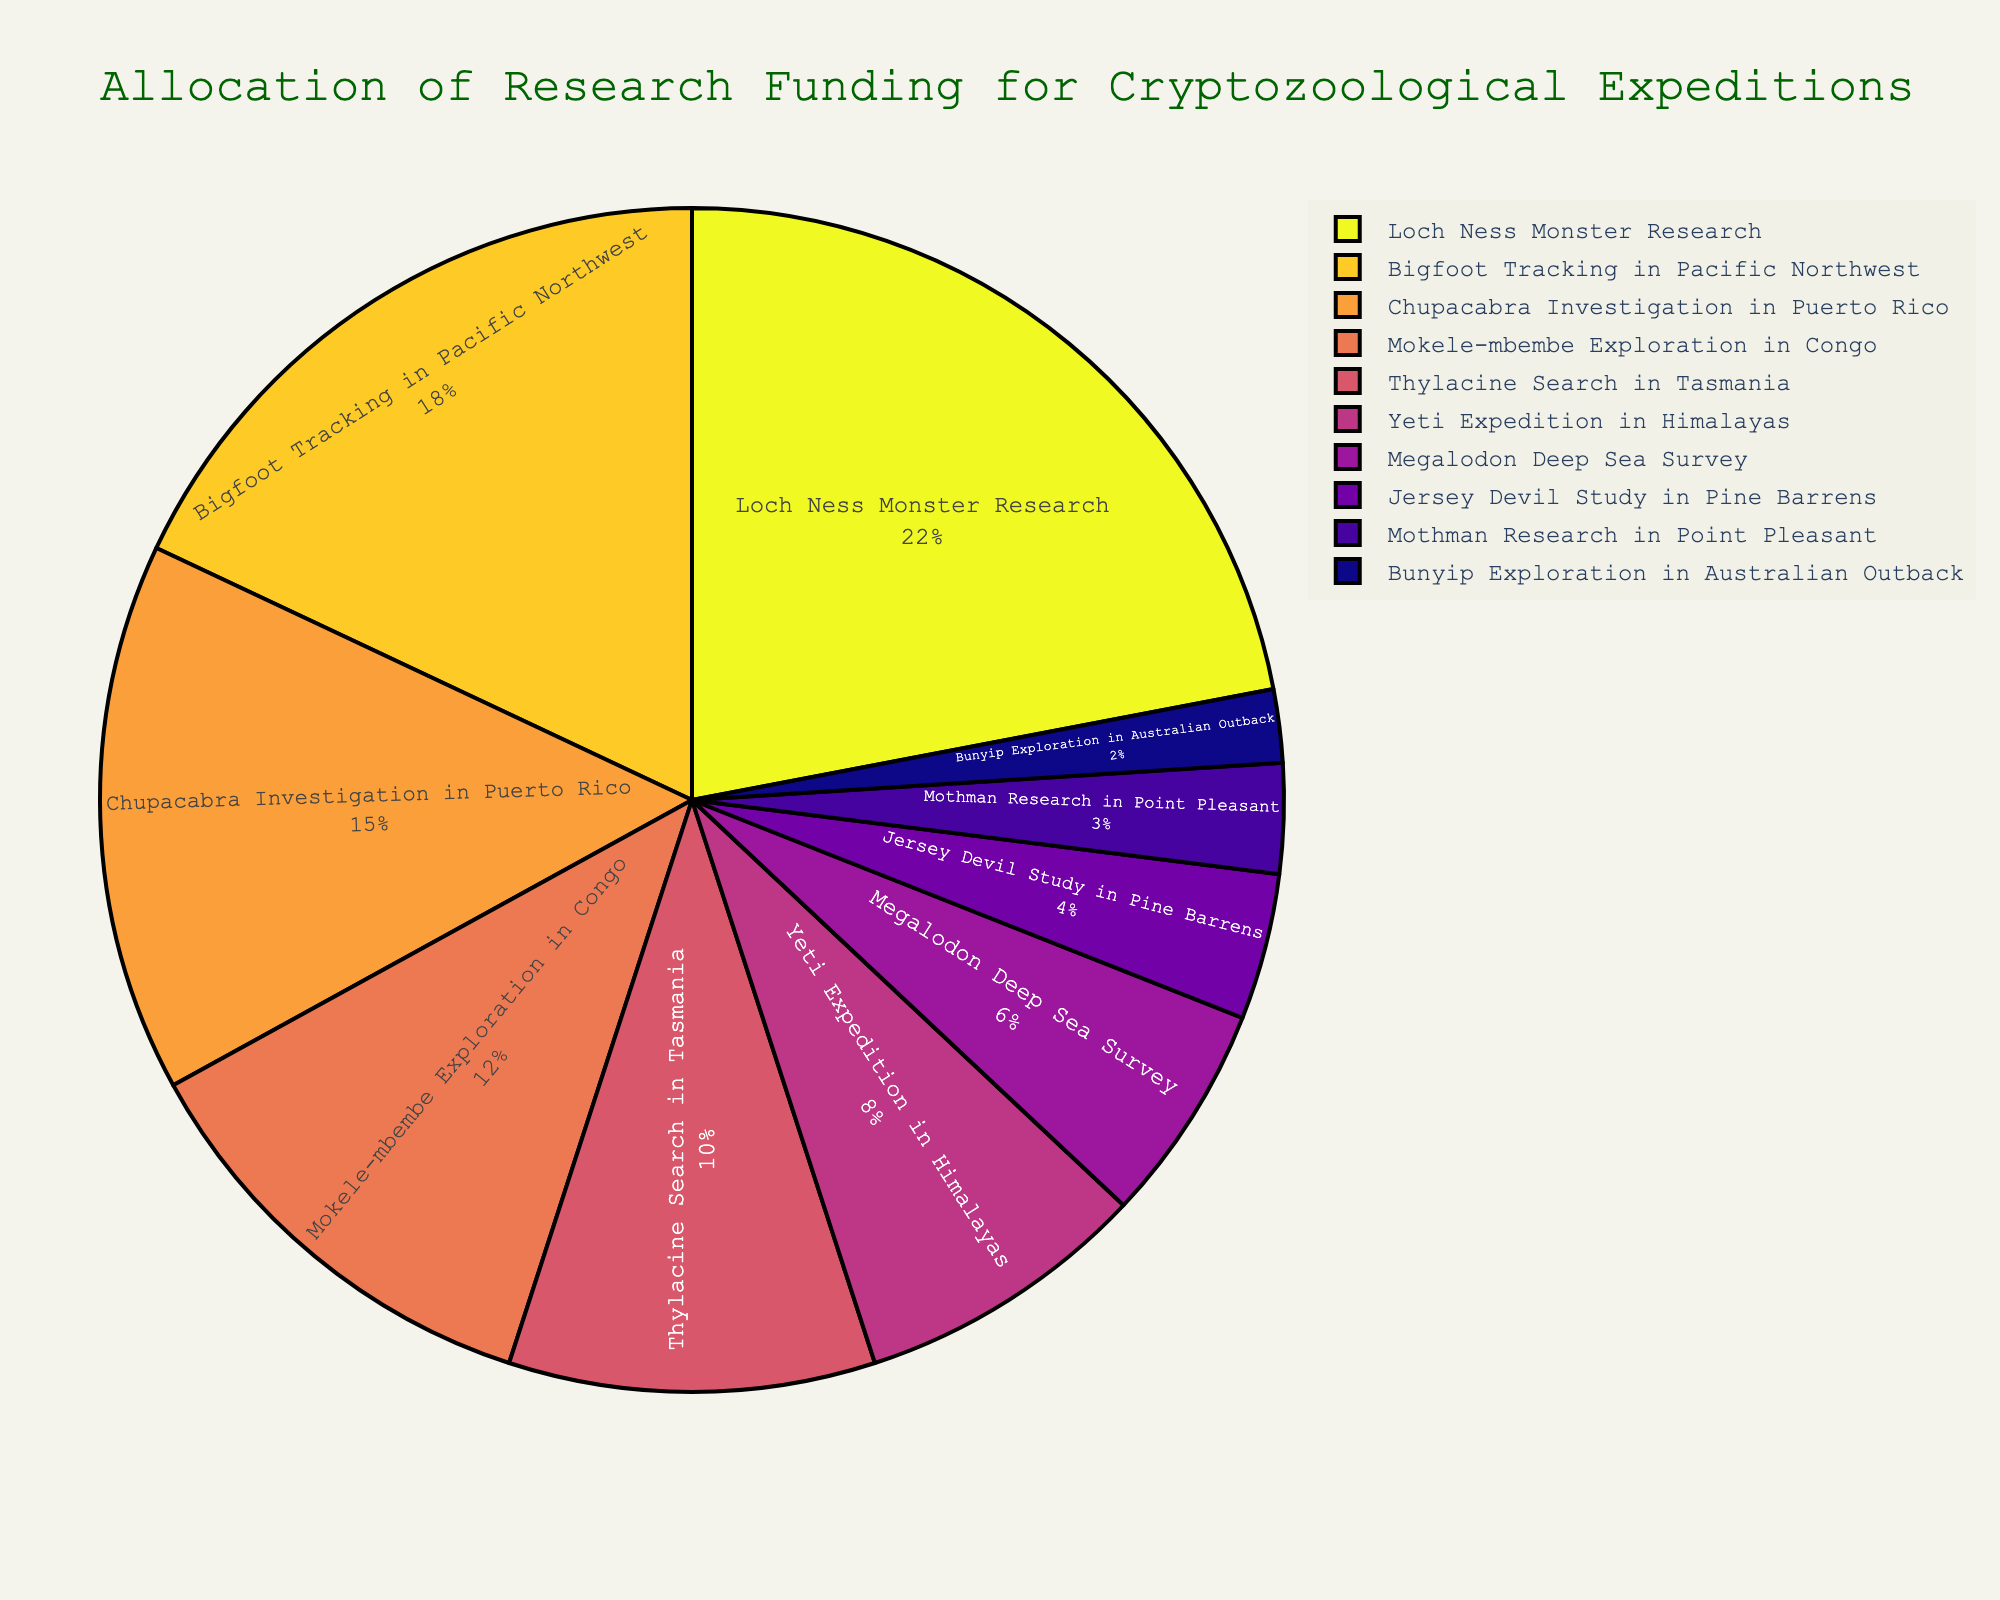Which expedition received the highest percentage of funding? The figure shows the allocation of research funding for various cryptozoological expeditions with percentages labeled. By finding the largest percentage in the pie chart, we identify 22% for Loch Ness Monster Research.
Answer: Loch Ness Monster Research What is the combined funding percentage for Bigfoot Tracking and Chupacabra Investigation? To find the combined funding, we sum the funding percentages for Bigfoot Tracking (18%) and Chupacabra Investigation (15%). Thus, 18 + 15 = 33.
Answer: 33% Which expedition received double the funding percentage of the Yeti Expedition? The funding percentage for the Yeti Expedition is 8%. Doubling this amount gives us 8 * 2 = 16%. The closest funding percentage in the pie chart to 16% is 15% for Chupacabra Investigation.
Answer: Chupacabra Investigation What is the difference in funding percentage between the highest and lowest funded expeditions? The highest funded expedition is Loch Ness Monster Research with 22%, and the lowest is Bunyip Exploration with 2%. Subtract 2 from 22 to find the difference: 22 - 2 = 20.
Answer: 20% Which two expeditions together received the same funding percentage as Loch Ness Monster Research? The Loch Ness Monster Research received 22% funding. Looking for two expeditions whose combined funding equals 22%, we find Thylacine Search (10%) and Yeti Expedition (8%) together provide 10 + 8 = 18%. Including Mothman Research (3%) gives us 18 + 3 = 21. Finally, adding Jersey Devil Study (4%) to 18 makes 18 + 4 = 22, so the Thylacine Search (10%) and Megalodon Deep Sea Survey (6%) do it together: 10 + 6 = 22.
Answer: Thylacine Search and Megalodon Deep Sea Survey How does the funding for Mokele-mbembe Exploration compare to that of Thylacine Search? Mokele-mbembe Exploration received 12% funding, while Thylacine Search received 10% funding. Comparing these values, 12% is greater than 10%.
Answer: Mokele-mbembe Exploration has higher funding Which three expeditions received the least combined funding? By listing the lowest percentages, Bunyip Exploration (2%), Mothman Research (3%), and Jersey Devil Study (4%), their combined funding is 2 + 3 + 4 = 9%.
Answer: Bunyip Exploration, Mothman Research, Jersey Devil Study Is the funding allocated to the Megalodon Deep Sea Survey more than twice the funding for the Bunyip Exploration? Megalodon Deep Sea Survey has 6% funding and Bunyip Exploration has 2%. Twice the funding of Bunyip is 2 * 2 = 4%. Since 6% is greater than 4%, the funding for Megalodon is more than twice that of Bunyip.
Answer: Yes What is the average funding percentage of the top three funded expeditions? Top three expeditions are Loch Ness Monster Research (22%), Bigfoot Tracking (18%), and Chupacabra Investigation (15%). The sum of these percentages is 22 + 18 + 15 = 55%. The average is 55/3 = 18.33.
Answer: 18.33% 